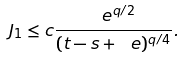Convert formula to latex. <formula><loc_0><loc_0><loc_500><loc_500>J _ { 1 } \leq c \frac { \ e ^ { q / 2 } } { ( t - s + \ e ) ^ { q / 4 } } .</formula> 